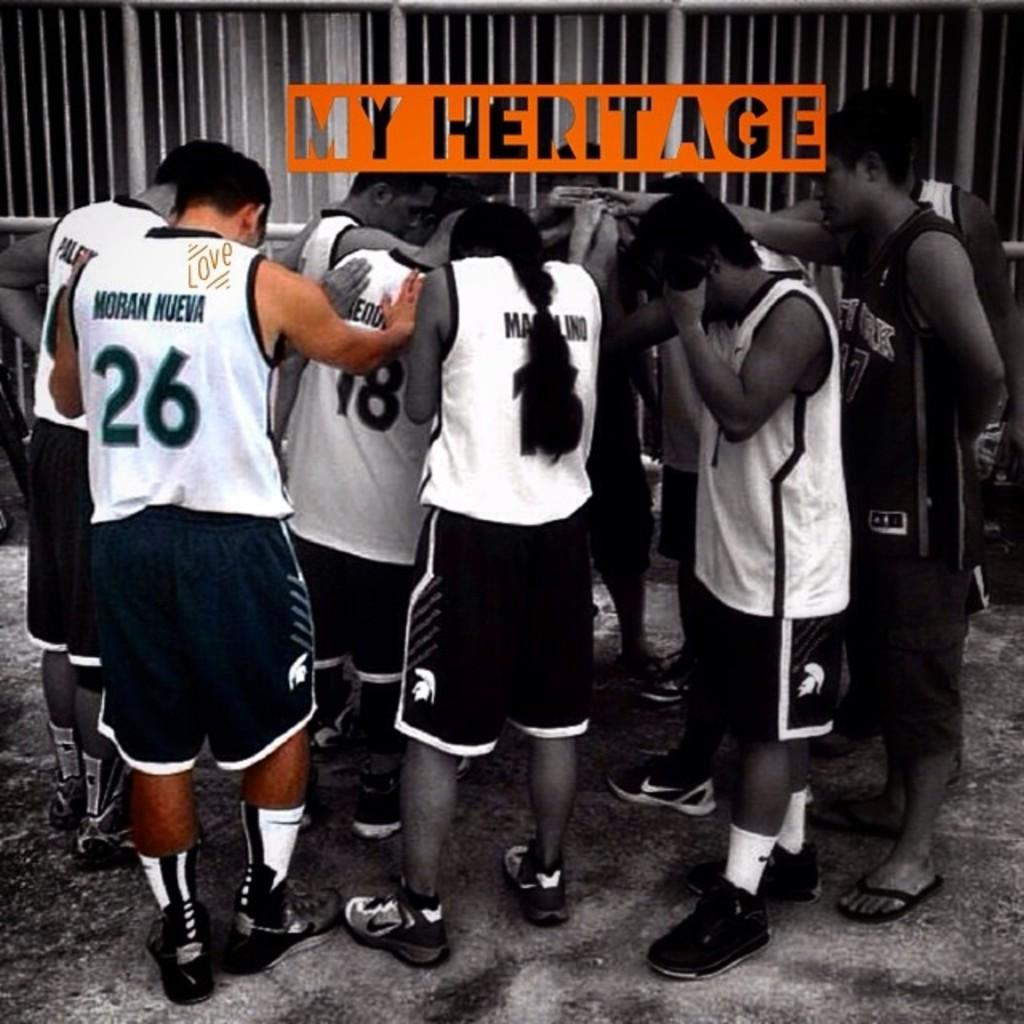<image>
Render a clear and concise summary of the photo. Moran Nueva, 26, prays with other basketball players. 